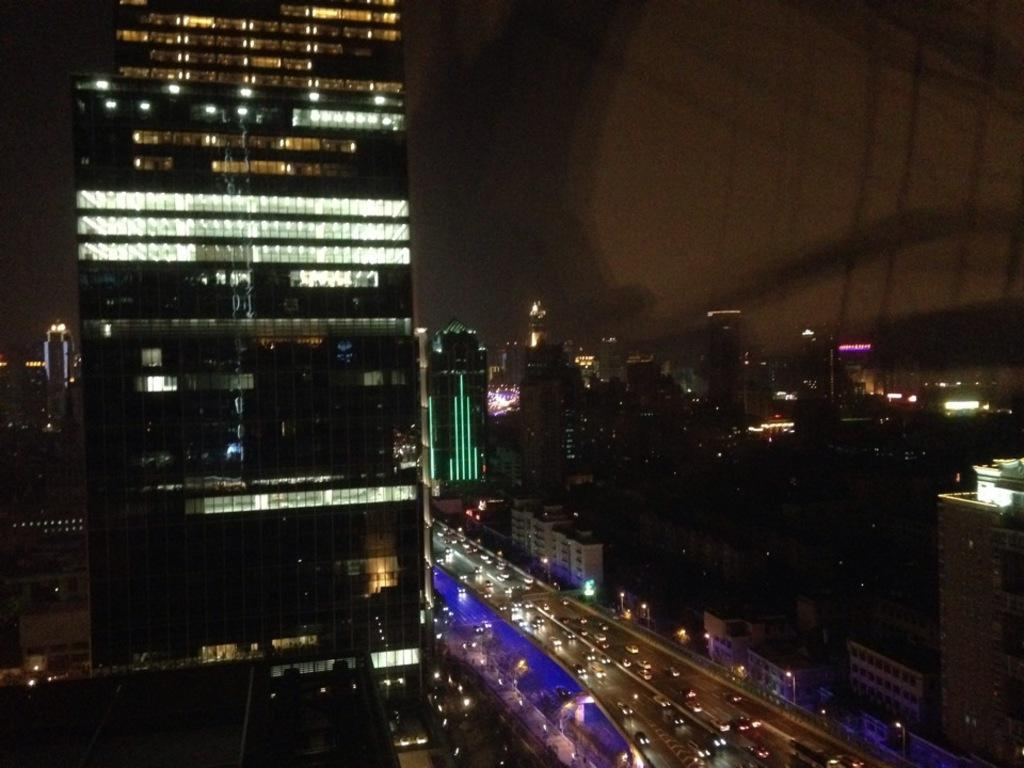What type of structures are present in the image? There are buildings with lighting in the image. What else can be seen in the image besides the buildings? Vehicles are visible moving on the road in the image. Where is the secretary working in the image? There is no secretary present in the image. What year is depicted in the image? The image does not depict a specific year; it shows buildings and vehicles. 